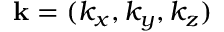Convert formula to latex. <formula><loc_0><loc_0><loc_500><loc_500>k = ( k _ { x } , k _ { y } , k _ { z } )</formula> 